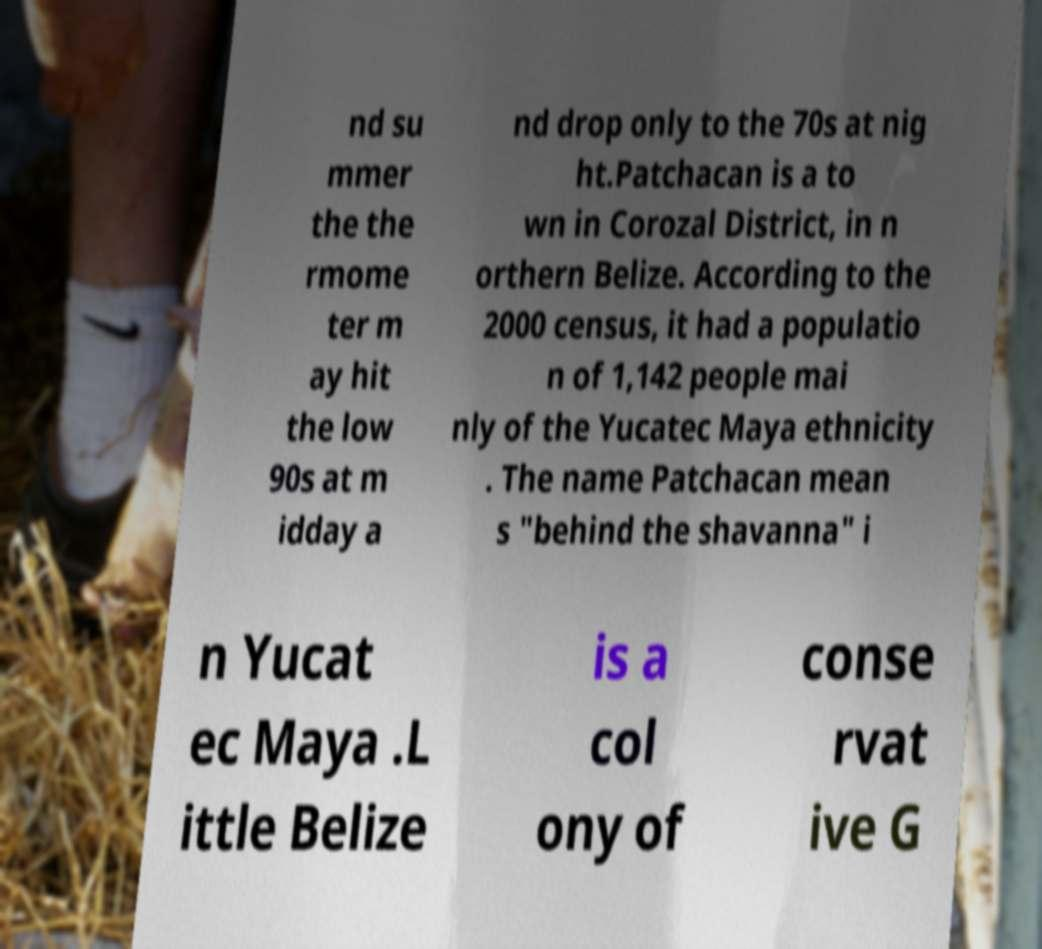There's text embedded in this image that I need extracted. Can you transcribe it verbatim? nd su mmer the the rmome ter m ay hit the low 90s at m idday a nd drop only to the 70s at nig ht.Patchacan is a to wn in Corozal District, in n orthern Belize. According to the 2000 census, it had a populatio n of 1,142 people mai nly of the Yucatec Maya ethnicity . The name Patchacan mean s "behind the shavanna" i n Yucat ec Maya .L ittle Belize is a col ony of conse rvat ive G 